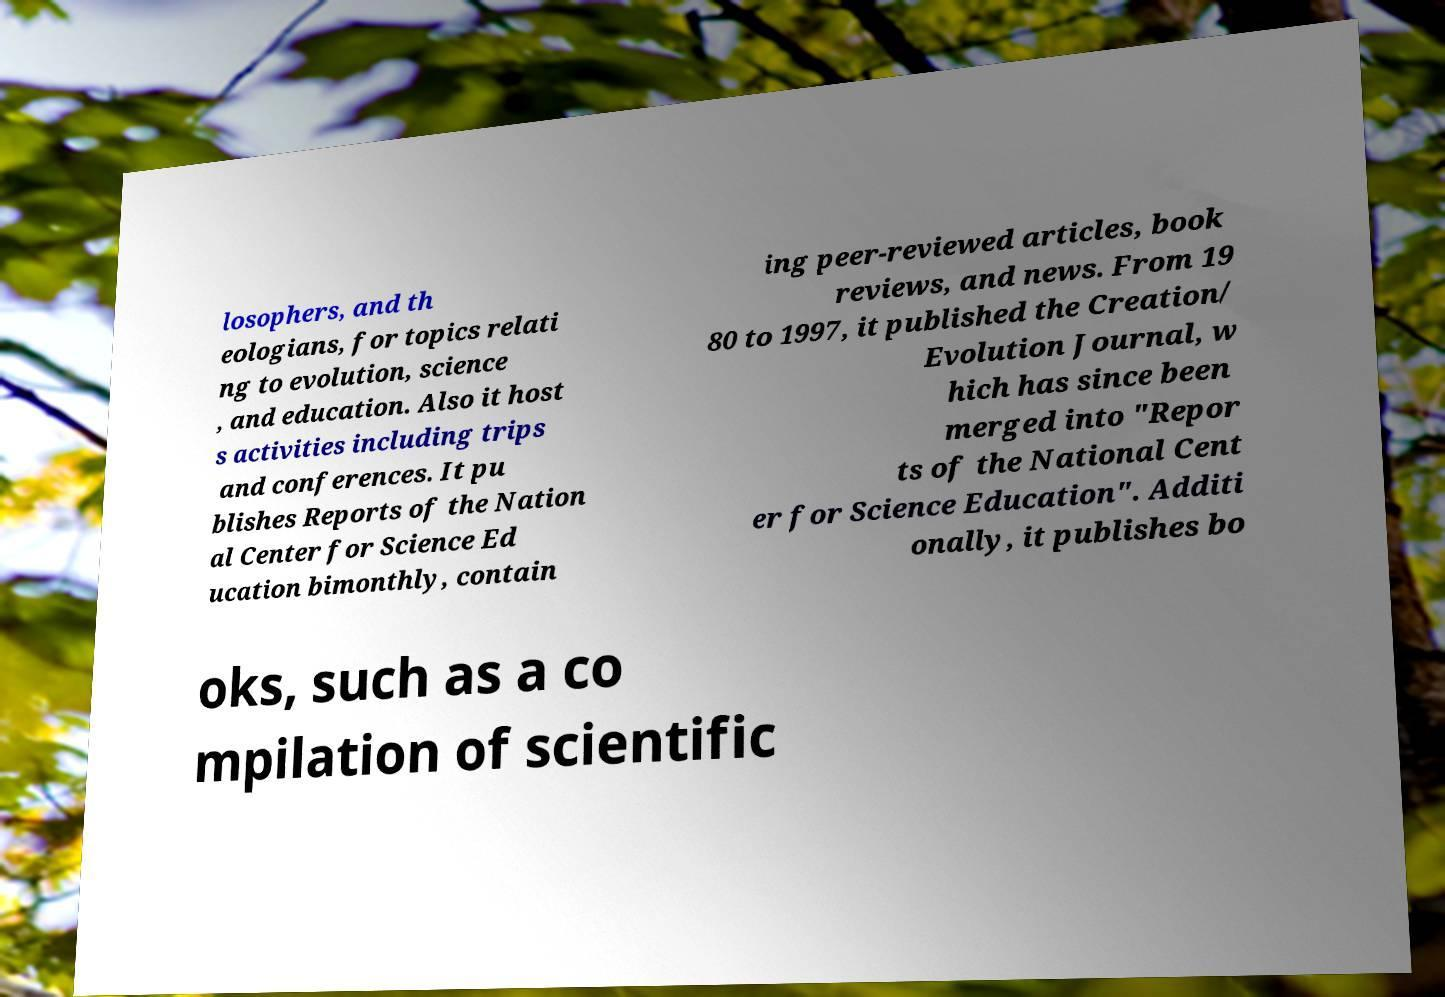Could you extract and type out the text from this image? losophers, and th eologians, for topics relati ng to evolution, science , and education. Also it host s activities including trips and conferences. It pu blishes Reports of the Nation al Center for Science Ed ucation bimonthly, contain ing peer-reviewed articles, book reviews, and news. From 19 80 to 1997, it published the Creation/ Evolution Journal, w hich has since been merged into "Repor ts of the National Cent er for Science Education". Additi onally, it publishes bo oks, such as a co mpilation of scientific 